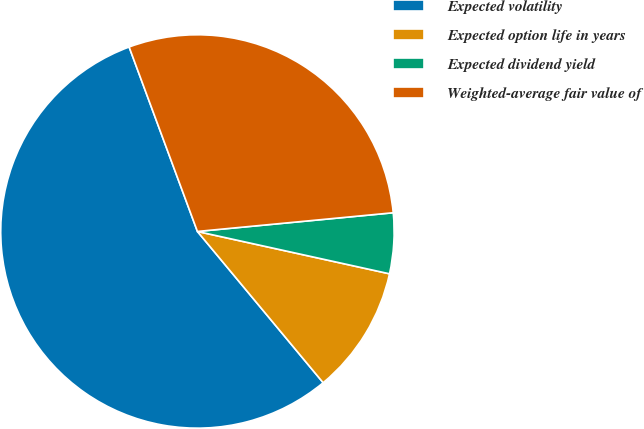Convert chart. <chart><loc_0><loc_0><loc_500><loc_500><pie_chart><fcel>Expected volatility<fcel>Expected option life in years<fcel>Expected dividend yield<fcel>Weighted-average fair value of<nl><fcel>55.4%<fcel>10.51%<fcel>4.97%<fcel>29.13%<nl></chart> 